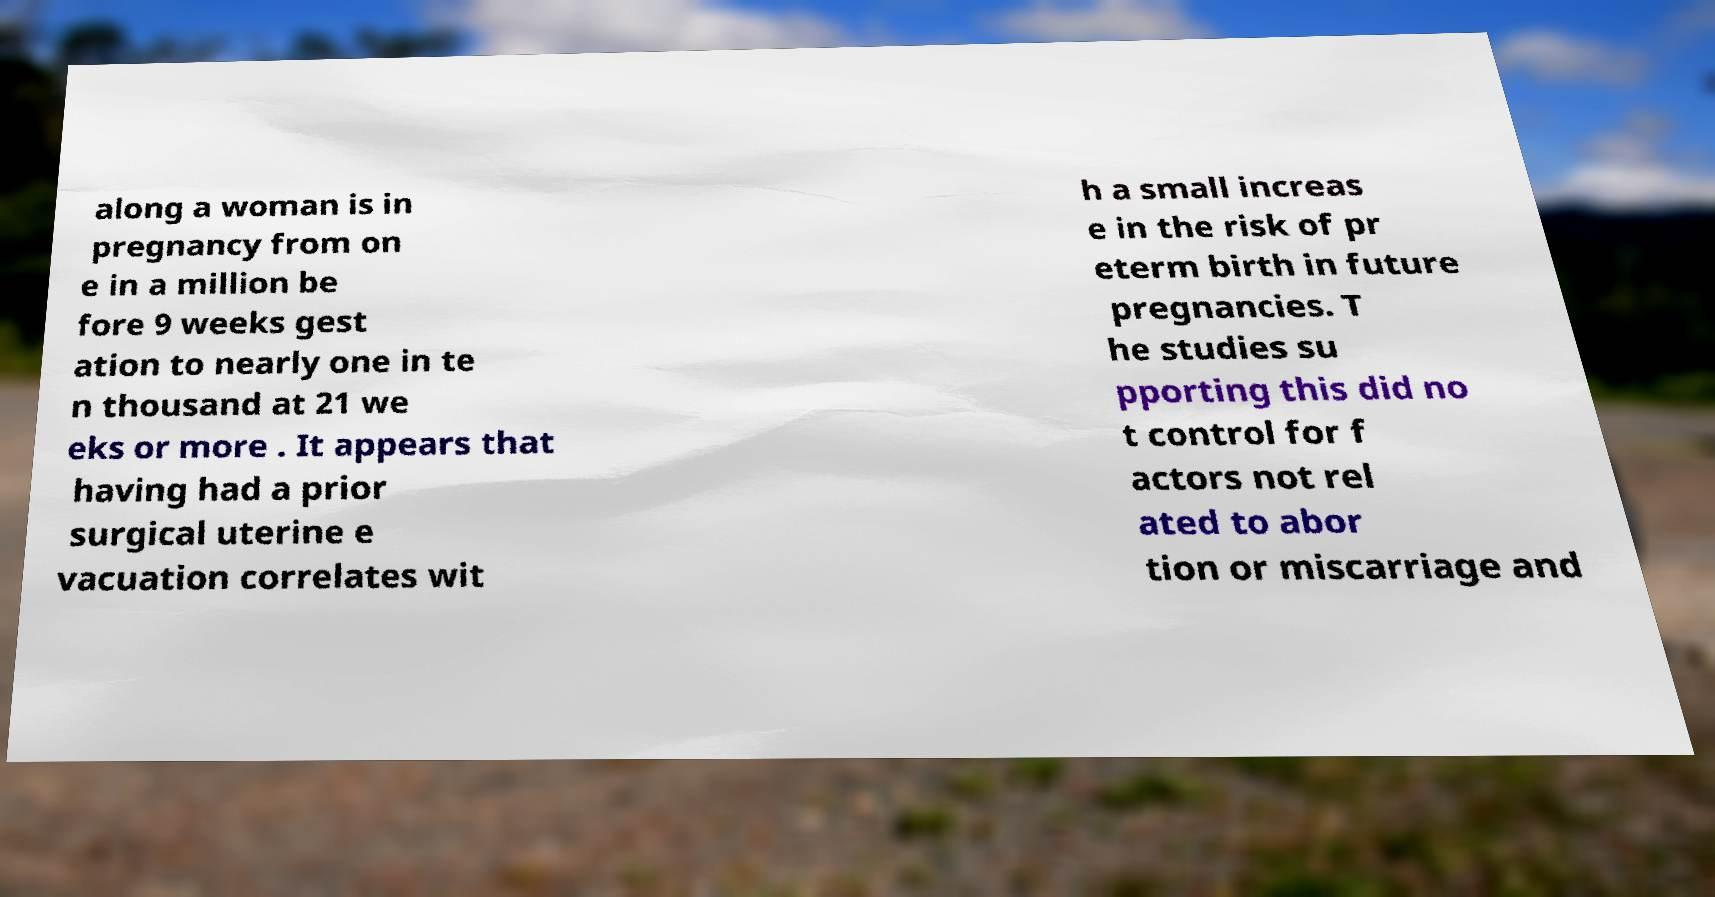Please identify and transcribe the text found in this image. along a woman is in pregnancy from on e in a million be fore 9 weeks gest ation to nearly one in te n thousand at 21 we eks or more . It appears that having had a prior surgical uterine e vacuation correlates wit h a small increas e in the risk of pr eterm birth in future pregnancies. T he studies su pporting this did no t control for f actors not rel ated to abor tion or miscarriage and 